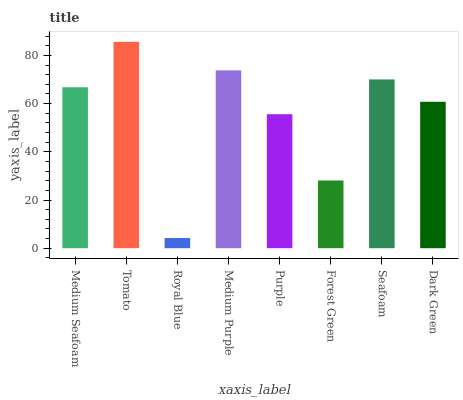Is Royal Blue the minimum?
Answer yes or no. Yes. Is Tomato the maximum?
Answer yes or no. Yes. Is Tomato the minimum?
Answer yes or no. No. Is Royal Blue the maximum?
Answer yes or no. No. Is Tomato greater than Royal Blue?
Answer yes or no. Yes. Is Royal Blue less than Tomato?
Answer yes or no. Yes. Is Royal Blue greater than Tomato?
Answer yes or no. No. Is Tomato less than Royal Blue?
Answer yes or no. No. Is Medium Seafoam the high median?
Answer yes or no. Yes. Is Dark Green the low median?
Answer yes or no. Yes. Is Forest Green the high median?
Answer yes or no. No. Is Seafoam the low median?
Answer yes or no. No. 